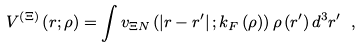<formula> <loc_0><loc_0><loc_500><loc_500>V ^ { \left ( \Xi \right ) } \left ( { r ; \rho } \right ) = \int { v _ { \Xi N } \left ( { \left | { { r } - { r ^ { \prime } } } \right | ; k _ { F } \left ( \rho \right ) } \right ) \rho \left ( { r ^ { \prime } } \right ) d ^ { 3 } r ^ { \prime } } \ ,</formula> 